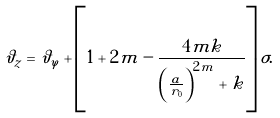<formula> <loc_0><loc_0><loc_500><loc_500>\vartheta _ { z } = \vartheta _ { \varphi } + \left [ 1 + 2 m - \frac { 4 m k } { \left ( \frac { a } { r _ { 0 } } \right ) ^ { 2 m } + k } \right ] \sigma .</formula> 